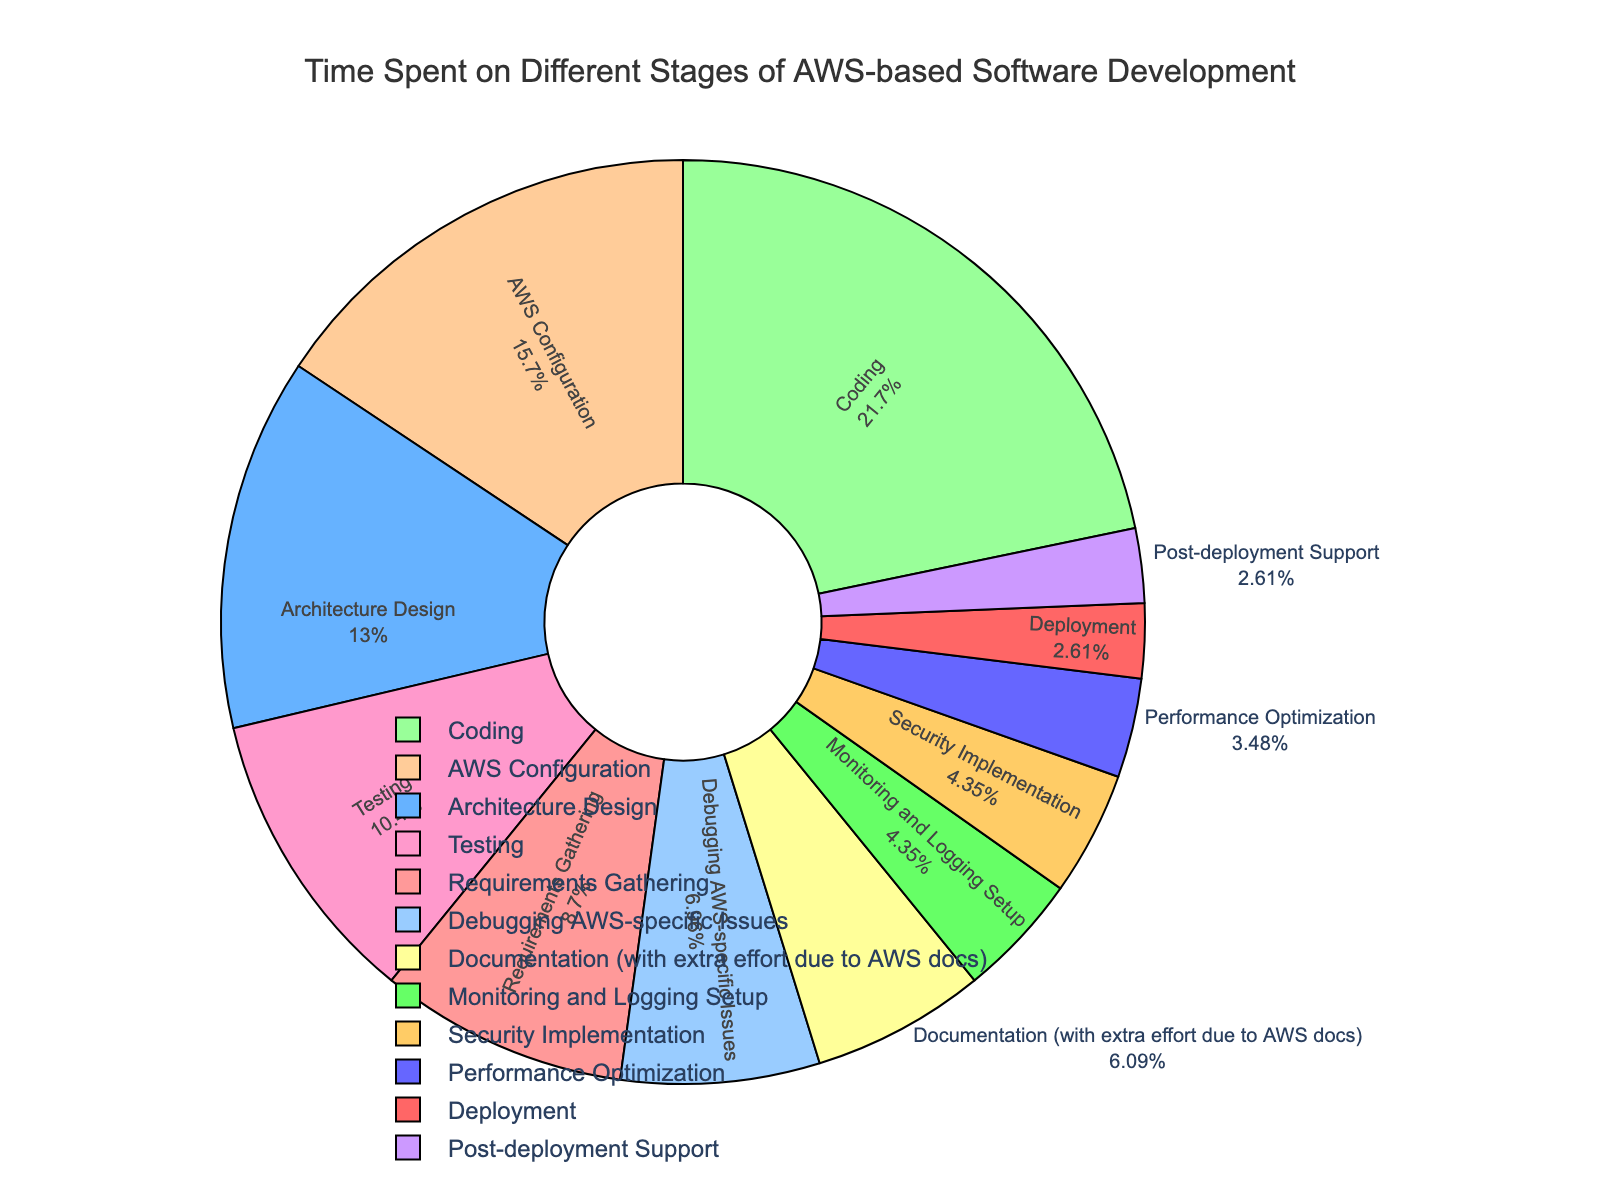How much total time is spent on stages related to AWS-specific activities? To find the total time spent on AWS-specific activities, sum the percentages of "AWS Configuration", "Debugging AWS-specific Issues", and "Documentation (with extra effort due to AWS docs)". That equals 18% + 8% + 7% = 33%.
Answer: 33% Which stage takes the most time, and what percentage is it? The stage with the largest percentage on the pie chart is "Coding", which takes up 25% of the time.
Answer: Coding, 25% How does the time spent on Performance Optimization compare to Security Implementation? Performance Optimization takes 4%, whereas Security Implementation takes 5%, so Performance Optimization spends 1% less.
Answer: 1% less What is the combined percentage for stages related to testing (including Testing and Debugging AWS-specific Issues)? To find this, add the percentages of "Testing" and "Debugging AWS-specific Issues". That is 12% + 8% = 20%.
Answer: 20% What color represents the "Deployment" stage, and what percentage does it occupy? The "Deployment" stage is represented in light blue, and it occupies 3% of the time.
Answer: Light blue, 3% How does the time spent on 'Monitoring and Logging Setup' compare to 'Post-deployment Support'? "Monitoring and Logging Setup" takes up 5%, while "Post-deployment Support" takes up 3%. Therefore, "Monitoring and Logging Setup" takes 2% more time.
Answer: 2% more What is the total time spent on non-coding activities excluding AWS-specific ones and documentation? First identify the stages: Requirements Gathering, Architecture Design, Testing, Deployment, Monitoring and Logging Setup, Security Implementation, Post-deployment Support. Sum their percentages: 10% + 15% + 12% + 3% + 5% + 5% + 3% = 53%.
Answer: 53% Which stage takes more time, "Requirements Gathering" or "Architecture Design", and by how much? "Architecture Design" takes 15%, while "Requirements Gathering" takes 10%. Therefore, "Architecture Design" takes 5% more time.
Answer: 5% more Is there any stage that shares the same percentage as another? If so, which stages? The stages "Monitoring and Logging Setup" and "Security Implementation" share the same percentage of 5%.
Answer: Monitoring and Logging Setup and Security Implementation 